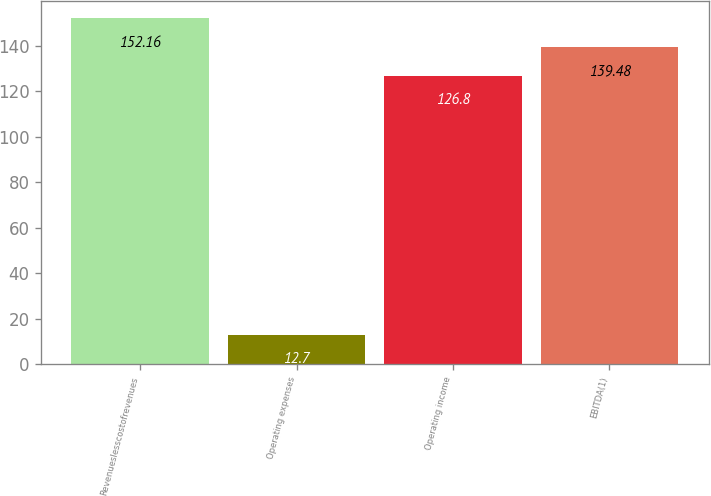<chart> <loc_0><loc_0><loc_500><loc_500><bar_chart><fcel>Revenueslesscostofrevenues<fcel>Operating expenses<fcel>Operating income<fcel>EBITDA(1)<nl><fcel>152.16<fcel>12.7<fcel>126.8<fcel>139.48<nl></chart> 